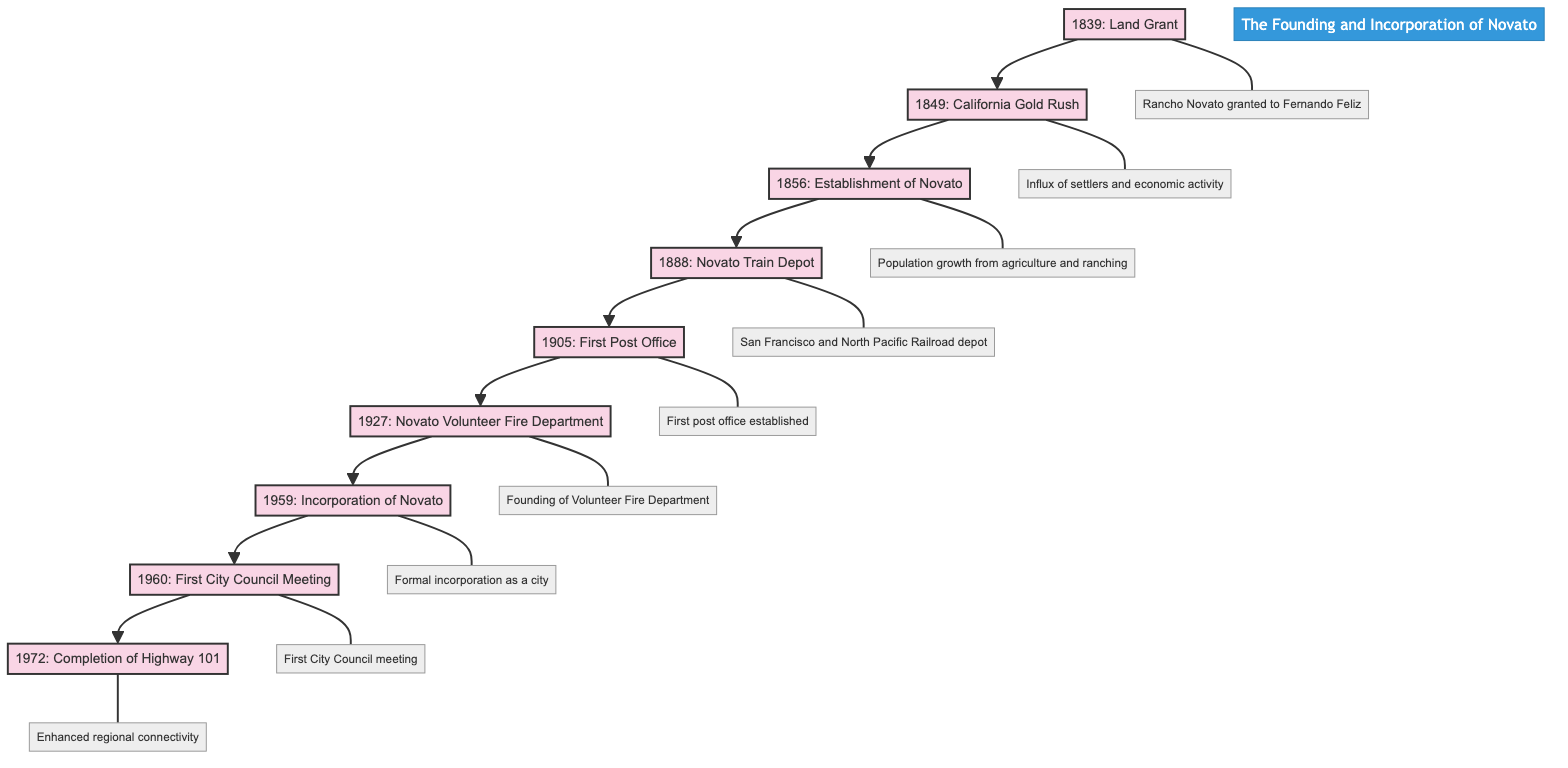What year was Novato formally established? The diagram shows that the establishment of Novato occurred in the year 1856.
Answer: 1856 What event occurred immediately before the incorporation of Novato? According to the flow of the diagram, the event that occurred immediately before incorporation in 1959 was the founding of the Novato Volunteer Fire Department in 1927.
Answer: Novato Volunteer Fire Department How many key historical events are included in the diagram? By counting the number of elements presented in the flowchart, there are a total of 9 key historical events listed.
Answer: 9 What significant milestone happened in 1849? The diagram indicates that in 1849, the California Gold Rush occurred, which brought significant changes to the region.
Answer: California Gold Rush What marked the first formal establishment of a government in Novato? The diagram points out that the first city council meeting in 1960 marked the establishment of local government in Novato.
Answer: First City Council Meeting Which event in the flowchart involved a transportation development? The diagram specifies that the Novato Train Depot was established in 1888, highlighting a significant transportation development in the area.
Answer: Novato Train Depot What was the function of the first post office established in Novato? Based on the diagram, the establishment of the first post office in 1905 formalized the community’s communication and postal services.
Answer: Formalizing the community Which year saw the completion of Highway 101? The diagram directly states that the final section of Highway 101 was completed in 1972.
Answer: 1972 What was the impact of the California Gold Rush on Novato? The diagram describes that the California Gold Rush led to an influx of settlers and economic activity, greatly affecting Novato's development.
Answer: Influx of settlers and economic activity 